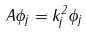<formula> <loc_0><loc_0><loc_500><loc_500>A \phi _ { j } = k _ { j } ^ { 2 } \phi _ { j }</formula> 